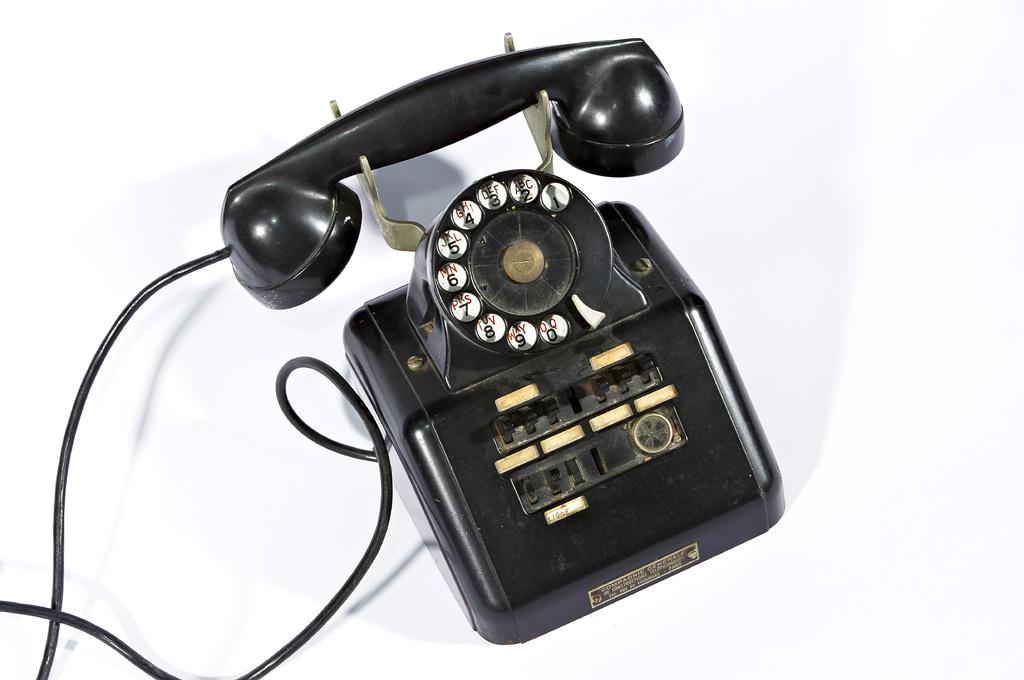Provide a one-sentence caption for the provided image. A black telephone has a Ligne label below the dial pad. 